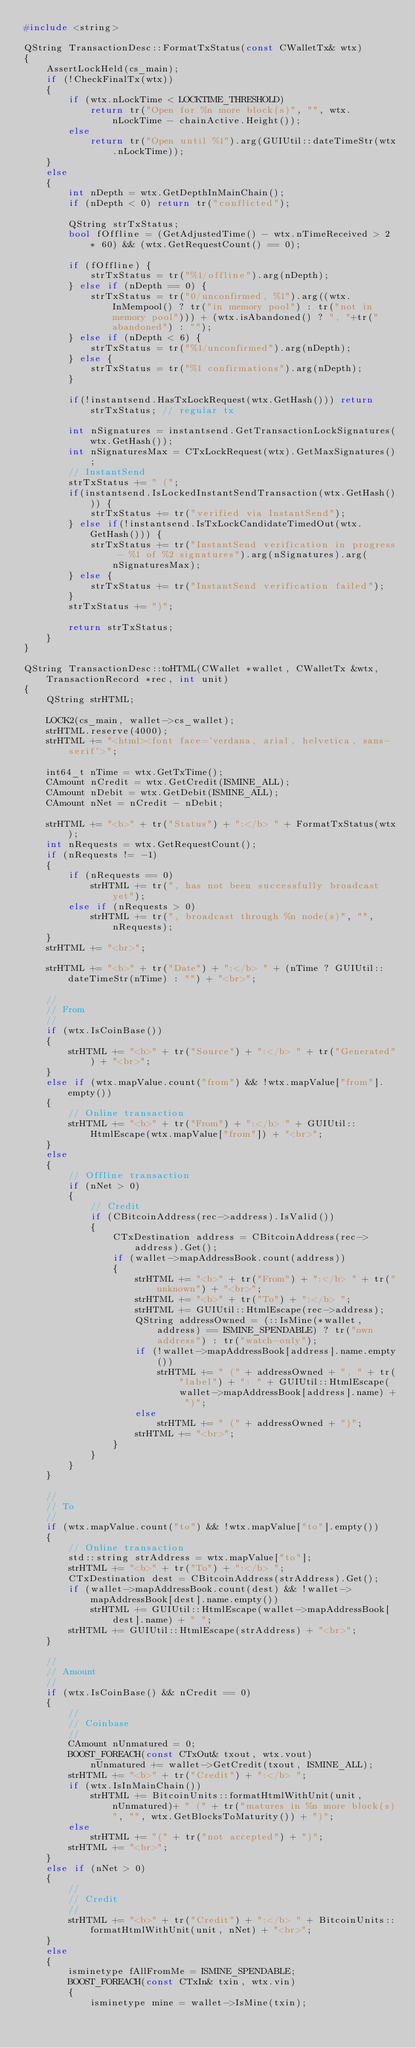<code> <loc_0><loc_0><loc_500><loc_500><_C++_>#include <string>

QString TransactionDesc::FormatTxStatus(const CWalletTx& wtx)
{
    AssertLockHeld(cs_main);
    if (!CheckFinalTx(wtx))
    {
        if (wtx.nLockTime < LOCKTIME_THRESHOLD)
            return tr("Open for %n more block(s)", "", wtx.nLockTime - chainActive.Height());
        else
            return tr("Open until %1").arg(GUIUtil::dateTimeStr(wtx.nLockTime));
    }
    else
    {
        int nDepth = wtx.GetDepthInMainChain();
        if (nDepth < 0) return tr("conflicted");

        QString strTxStatus;
        bool fOffline = (GetAdjustedTime() - wtx.nTimeReceived > 2 * 60) && (wtx.GetRequestCount() == 0);

        if (fOffline) {
            strTxStatus = tr("%1/offline").arg(nDepth);
        } else if (nDepth == 0) {
            strTxStatus = tr("0/unconfirmed, %1").arg((wtx.InMempool() ? tr("in memory pool") : tr("not in memory pool"))) + (wtx.isAbandoned() ? ", "+tr("abandoned") : "");
        } else if (nDepth < 6) {
            strTxStatus = tr("%1/unconfirmed").arg(nDepth);
        } else {
            strTxStatus = tr("%1 confirmations").arg(nDepth);
        }

        if(!instantsend.HasTxLockRequest(wtx.GetHash())) return strTxStatus; // regular tx

        int nSignatures = instantsend.GetTransactionLockSignatures(wtx.GetHash());
        int nSignaturesMax = CTxLockRequest(wtx).GetMaxSignatures();
        // InstantSend
        strTxStatus += " (";
        if(instantsend.IsLockedInstantSendTransaction(wtx.GetHash())) {
            strTxStatus += tr("verified via InstantSend");
        } else if(!instantsend.IsTxLockCandidateTimedOut(wtx.GetHash())) {
            strTxStatus += tr("InstantSend verification in progress - %1 of %2 signatures").arg(nSignatures).arg(nSignaturesMax);
        } else {
            strTxStatus += tr("InstantSend verification failed");
        }
        strTxStatus += ")";

        return strTxStatus;
    }
}

QString TransactionDesc::toHTML(CWallet *wallet, CWalletTx &wtx, TransactionRecord *rec, int unit)
{
    QString strHTML;

    LOCK2(cs_main, wallet->cs_wallet);
    strHTML.reserve(4000);
    strHTML += "<html><font face='verdana, arial, helvetica, sans-serif'>";

    int64_t nTime = wtx.GetTxTime();
    CAmount nCredit = wtx.GetCredit(ISMINE_ALL);
    CAmount nDebit = wtx.GetDebit(ISMINE_ALL);
    CAmount nNet = nCredit - nDebit;

    strHTML += "<b>" + tr("Status") + ":</b> " + FormatTxStatus(wtx);
    int nRequests = wtx.GetRequestCount();
    if (nRequests != -1)
    {
        if (nRequests == 0)
            strHTML += tr(", has not been successfully broadcast yet");
        else if (nRequests > 0)
            strHTML += tr(", broadcast through %n node(s)", "", nRequests);
    }
    strHTML += "<br>";

    strHTML += "<b>" + tr("Date") + ":</b> " + (nTime ? GUIUtil::dateTimeStr(nTime) : "") + "<br>";

    //
    // From
    //
    if (wtx.IsCoinBase())
    {
        strHTML += "<b>" + tr("Source") + ":</b> " + tr("Generated") + "<br>";
    }
    else if (wtx.mapValue.count("from") && !wtx.mapValue["from"].empty())
    {
        // Online transaction
        strHTML += "<b>" + tr("From") + ":</b> " + GUIUtil::HtmlEscape(wtx.mapValue["from"]) + "<br>";
    }
    else
    {
        // Offline transaction
        if (nNet > 0)
        {
            // Credit
            if (CBitcoinAddress(rec->address).IsValid())
            {
                CTxDestination address = CBitcoinAddress(rec->address).Get();
                if (wallet->mapAddressBook.count(address))
                {
                    strHTML += "<b>" + tr("From") + ":</b> " + tr("unknown") + "<br>";
                    strHTML += "<b>" + tr("To") + ":</b> ";
                    strHTML += GUIUtil::HtmlEscape(rec->address);
                    QString addressOwned = (::IsMine(*wallet, address) == ISMINE_SPENDABLE) ? tr("own address") : tr("watch-only");
                    if (!wallet->mapAddressBook[address].name.empty())
                        strHTML += " (" + addressOwned + ", " + tr("label") + ": " + GUIUtil::HtmlEscape(wallet->mapAddressBook[address].name) + ")";
                    else
                        strHTML += " (" + addressOwned + ")";
                    strHTML += "<br>";
                }
            }
        }
    }

    //
    // To
    //
    if (wtx.mapValue.count("to") && !wtx.mapValue["to"].empty())
    {
        // Online transaction
        std::string strAddress = wtx.mapValue["to"];
        strHTML += "<b>" + tr("To") + ":</b> ";
        CTxDestination dest = CBitcoinAddress(strAddress).Get();
        if (wallet->mapAddressBook.count(dest) && !wallet->mapAddressBook[dest].name.empty())
            strHTML += GUIUtil::HtmlEscape(wallet->mapAddressBook[dest].name) + " ";
        strHTML += GUIUtil::HtmlEscape(strAddress) + "<br>";
    }

    //
    // Amount
    //
    if (wtx.IsCoinBase() && nCredit == 0)
    {
        //
        // Coinbase
        //
        CAmount nUnmatured = 0;
        BOOST_FOREACH(const CTxOut& txout, wtx.vout)
            nUnmatured += wallet->GetCredit(txout, ISMINE_ALL);
        strHTML += "<b>" + tr("Credit") + ":</b> ";
        if (wtx.IsInMainChain())
            strHTML += BitcoinUnits::formatHtmlWithUnit(unit, nUnmatured)+ " (" + tr("matures in %n more block(s)", "", wtx.GetBlocksToMaturity()) + ")";
        else
            strHTML += "(" + tr("not accepted") + ")";
        strHTML += "<br>";
    }
    else if (nNet > 0)
    {
        //
        // Credit
        //
        strHTML += "<b>" + tr("Credit") + ":</b> " + BitcoinUnits::formatHtmlWithUnit(unit, nNet) + "<br>";
    }
    else
    {
        isminetype fAllFromMe = ISMINE_SPENDABLE;
        BOOST_FOREACH(const CTxIn& txin, wtx.vin)
        {
            isminetype mine = wallet->IsMine(txin);</code> 